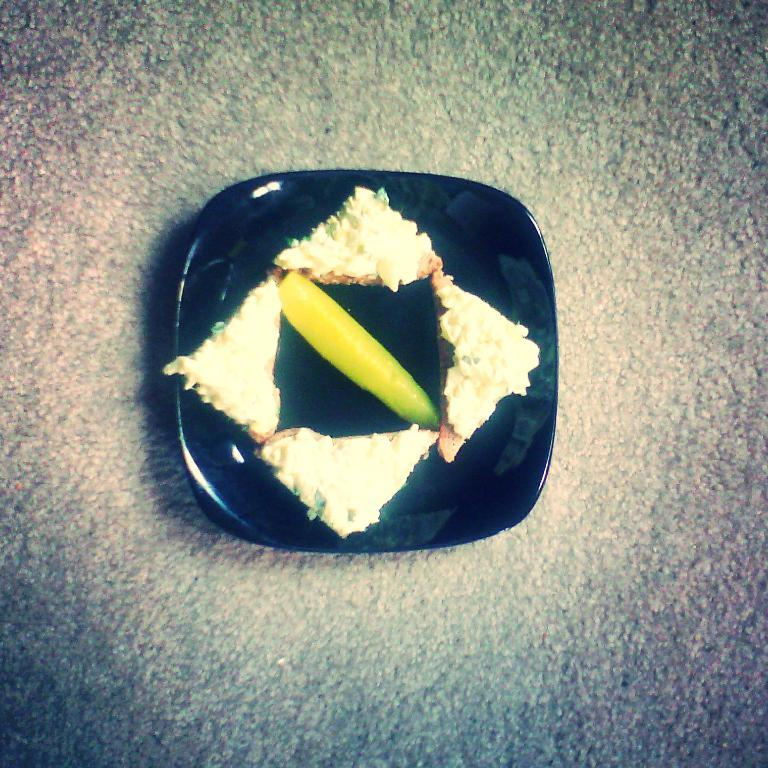What is present in the image related to food? There is food in the image. How is the food arranged or contained? The food is in a plate. Where is the plate with food located? The plate is placed on a surface. What type of cap can be seen on the food in the image? There is no cap present on the food in the image. How does the heat affect the food in the image? The provided facts do not mention any heat or temperature-related information about the food in the image. 